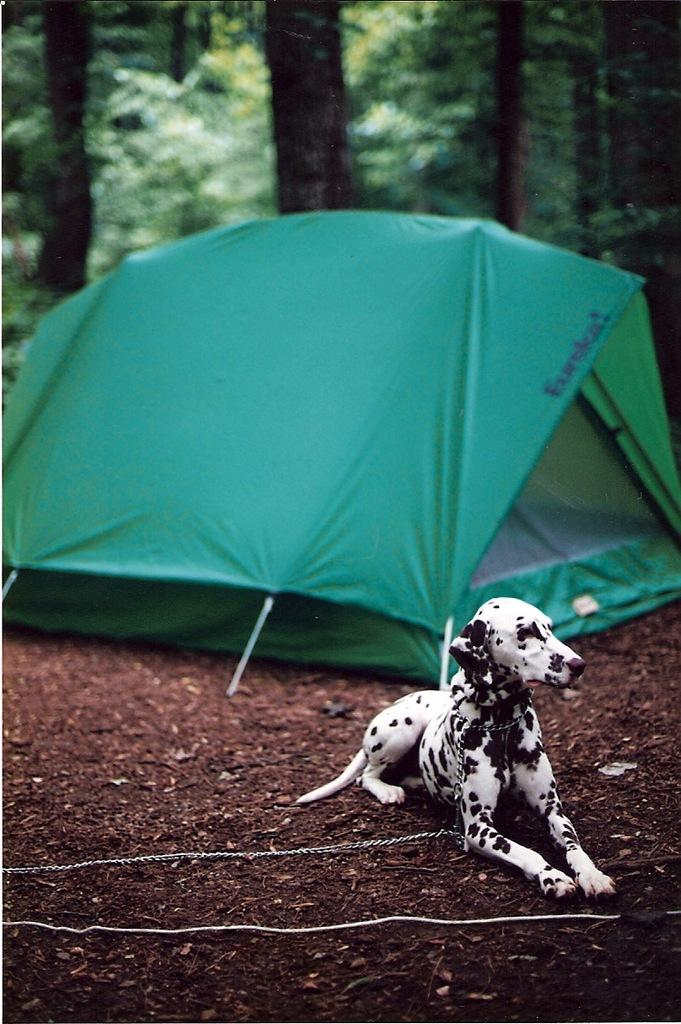What animal can be seen in the image? There is a dog in the image. What is the dog doing in the image? The dog is sitting on the ground. What is the color of the dog? The dog is black and white in color. What can be seen in the background of the image? There is a tent and trees in the background of the image. What is the color of the tent? The tent is green in color. What is the color of the trees? The trees are green in color. What type of pen is the dog holding in the image? There is no pen present in the image; the dog is sitting on the ground without holding any object. 